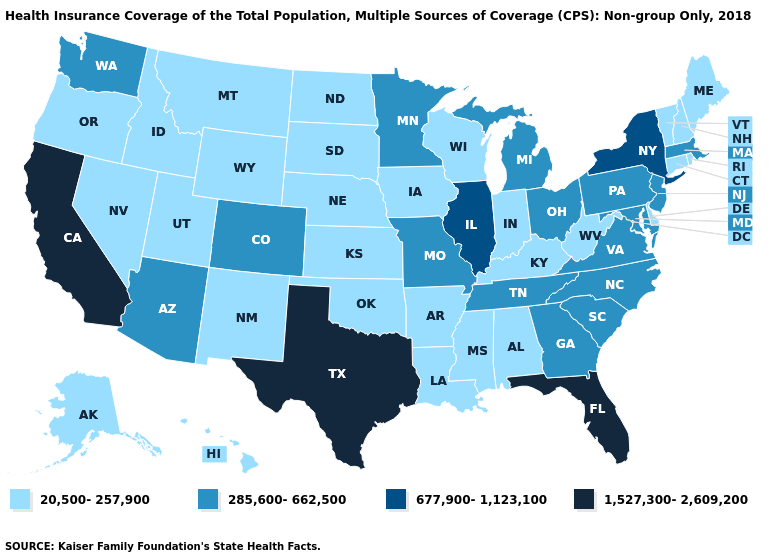Does Alabama have the same value as Pennsylvania?
Answer briefly. No. Among the states that border Wyoming , which have the highest value?
Answer briefly. Colorado. Does Iowa have the lowest value in the MidWest?
Short answer required. Yes. Which states have the lowest value in the USA?
Write a very short answer. Alabama, Alaska, Arkansas, Connecticut, Delaware, Hawaii, Idaho, Indiana, Iowa, Kansas, Kentucky, Louisiana, Maine, Mississippi, Montana, Nebraska, Nevada, New Hampshire, New Mexico, North Dakota, Oklahoma, Oregon, Rhode Island, South Dakota, Utah, Vermont, West Virginia, Wisconsin, Wyoming. What is the lowest value in states that border Indiana?
Quick response, please. 20,500-257,900. Which states have the highest value in the USA?
Quick response, please. California, Florida, Texas. What is the lowest value in the USA?
Short answer required. 20,500-257,900. Does the first symbol in the legend represent the smallest category?
Give a very brief answer. Yes. Name the states that have a value in the range 1,527,300-2,609,200?
Answer briefly. California, Florida, Texas. Name the states that have a value in the range 677,900-1,123,100?
Answer briefly. Illinois, New York. What is the lowest value in states that border Rhode Island?
Short answer required. 20,500-257,900. What is the value of Nevada?
Keep it brief. 20,500-257,900. What is the value of Vermont?
Short answer required. 20,500-257,900. What is the lowest value in the South?
Be succinct. 20,500-257,900. 